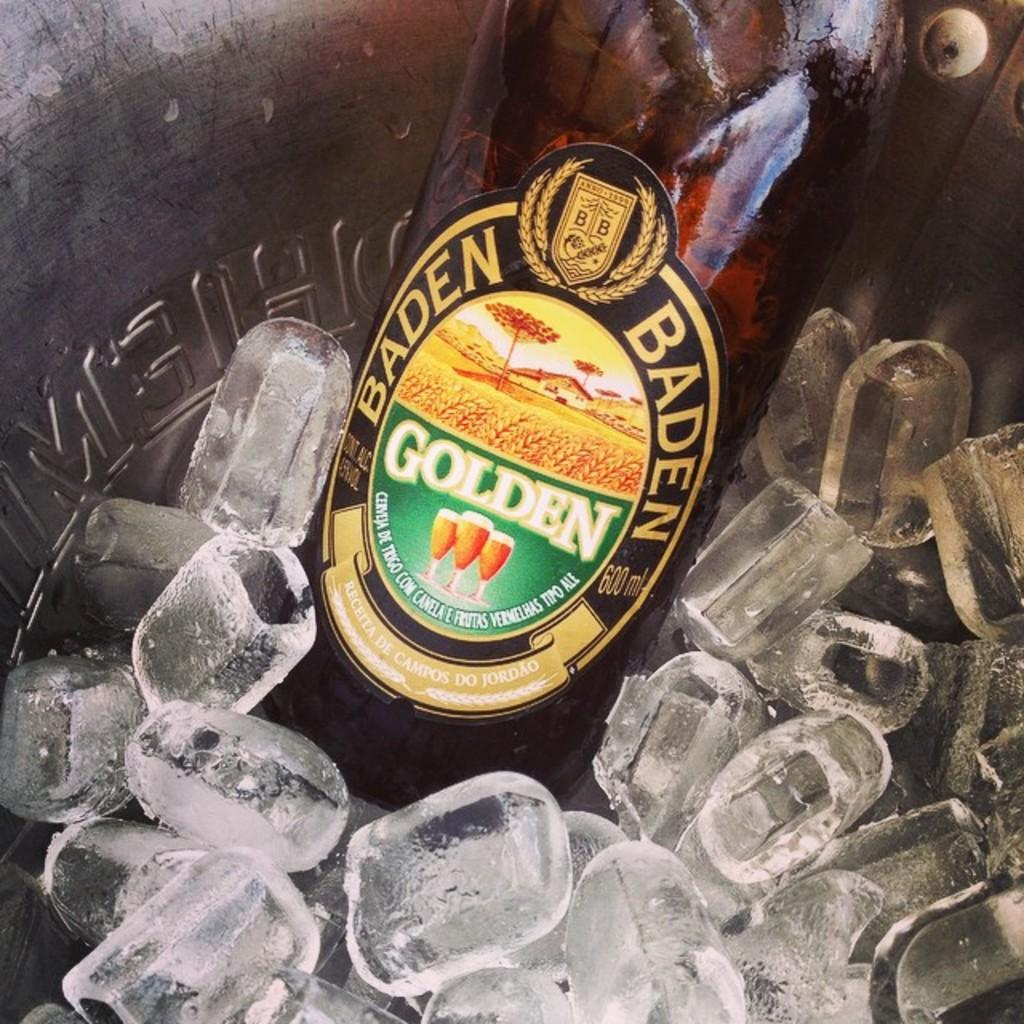<image>
Present a compact description of the photo's key features. A bottle of Baden Golden ale is in an ice bucket. 